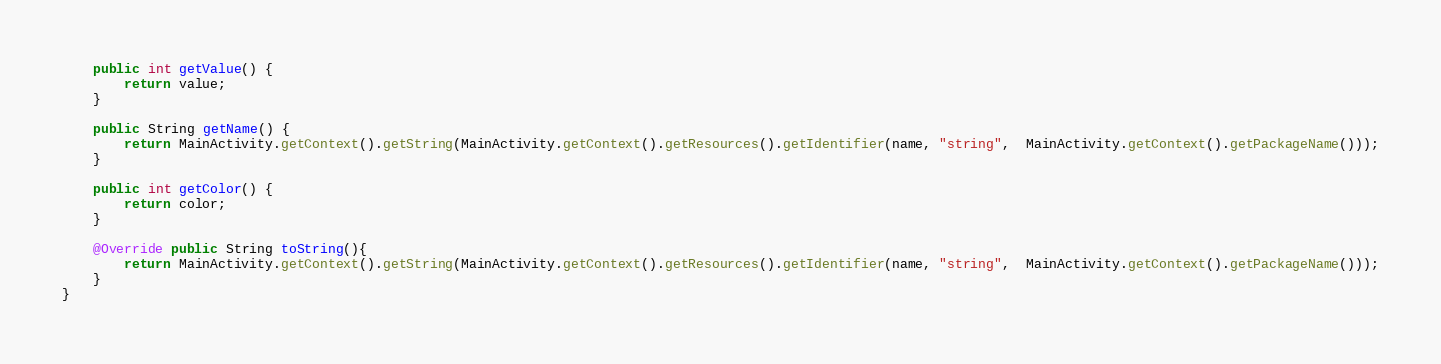Convert code to text. <code><loc_0><loc_0><loc_500><loc_500><_Java_>    public int getValue() {
        return value;
    }

    public String getName() {
        return MainActivity.getContext().getString(MainActivity.getContext().getResources().getIdentifier(name, "string",  MainActivity.getContext().getPackageName()));
    }

    public int getColor() {
        return color;
    }

    @Override public String toString(){
        return MainActivity.getContext().getString(MainActivity.getContext().getResources().getIdentifier(name, "string",  MainActivity.getContext().getPackageName()));
    }
}</code> 